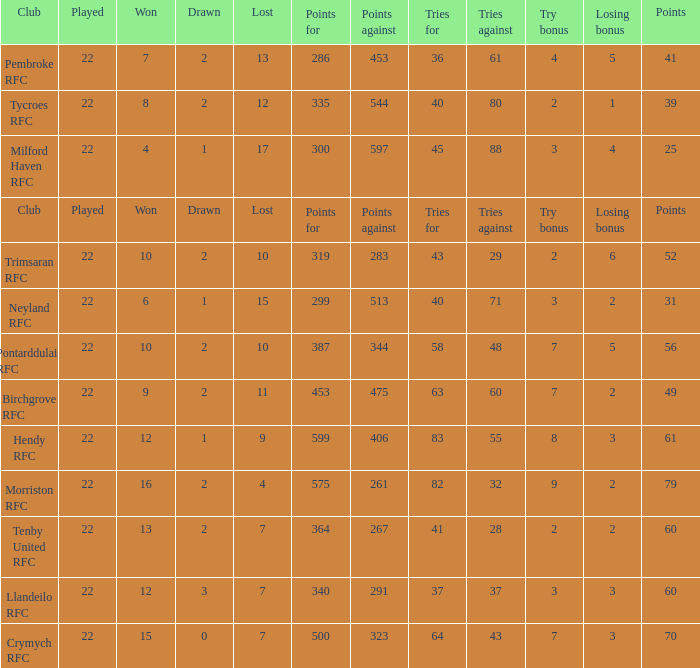 how many losing bonus with won being 10 and points against being 283 1.0. 